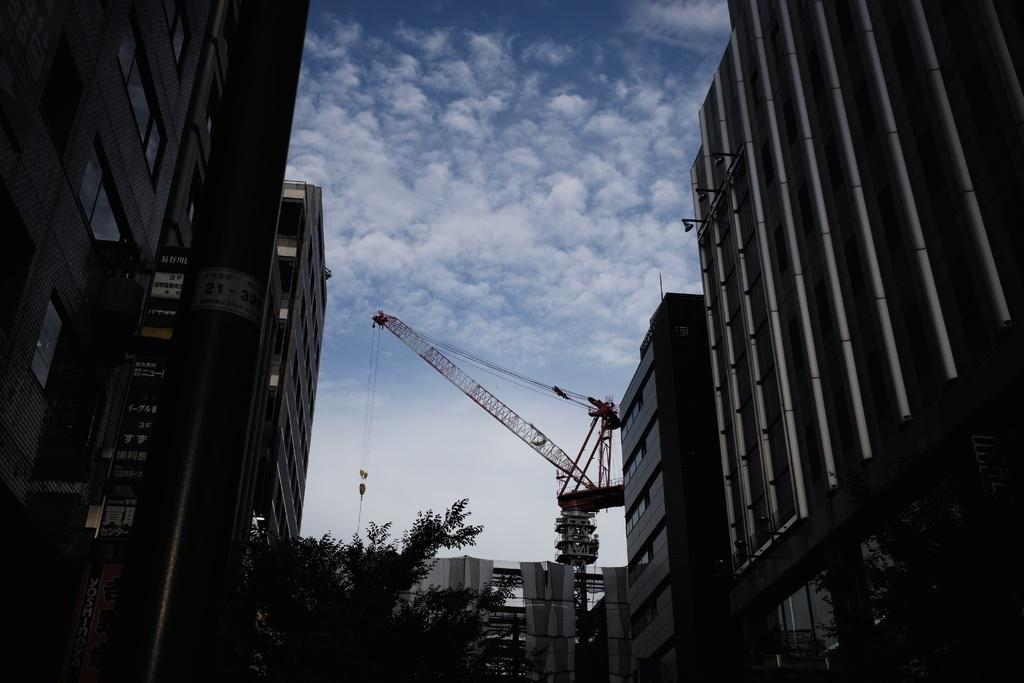What type of natural elements can be seen in the image? There are trees in the image. What type of man-made structures are visible in the image? There are buildings in the image. What architectural features can be seen in the buildings? There are windows and pillars in the image. What type of construction equipment is present in the image? There is a crane in the image. What part of the natural environment is visible in the image? The sky is visible in the image. Based on the presence of the sky and the absence of artificial lighting, when do you think the image was taken? The image was likely taken during the day. Reasoning: Let'g: Let's think step by step in order to produce the conversation. We start by identifying the main subjects and objects in the image based on the provided facts. We then formulate questions that focus on the location and characteristics of these subjects and objects, ensuring that each question can be answered definitively with the information given. We avoid yes/no questions and ensure that the language is simple and clear. Absurd Question/Answer: What language is being spoken by the trees in the image? Trees do not speak languages, so this question cannot be answered. Is there a cord visible in the image? There is no mention of a cord in the provided facts, so we cannot determine if one is present. What type of drug is being used by the crane in the image? There is no mention of a drug in the provided facts, and cranes do not use drugs. This question cannot be answered. 